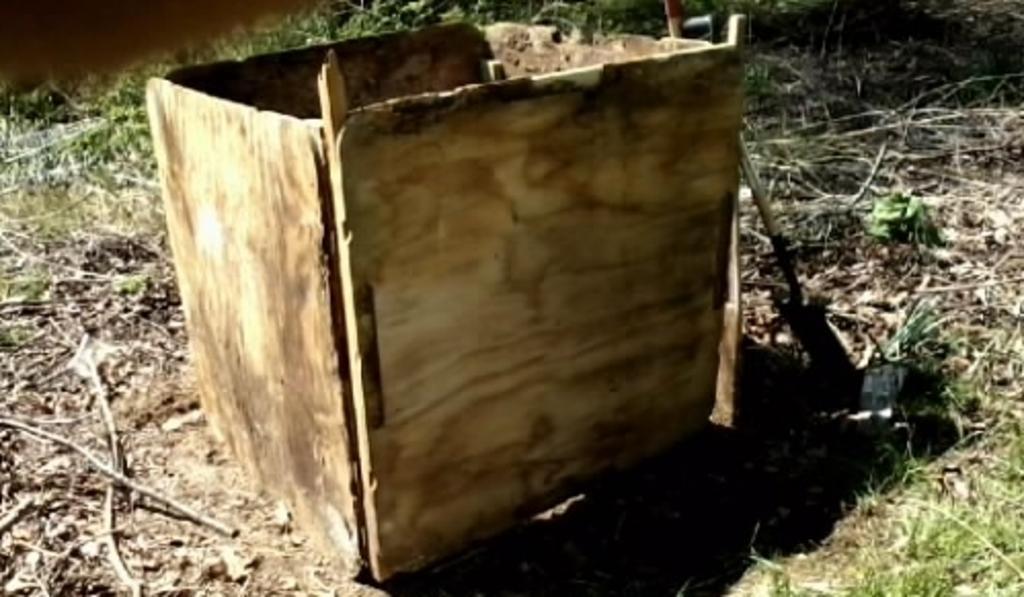How would you summarize this image in a sentence or two? In this picture we can see a wooden box in the middle, at the bottom there is grass and some sticks, in the background there are some plants. 